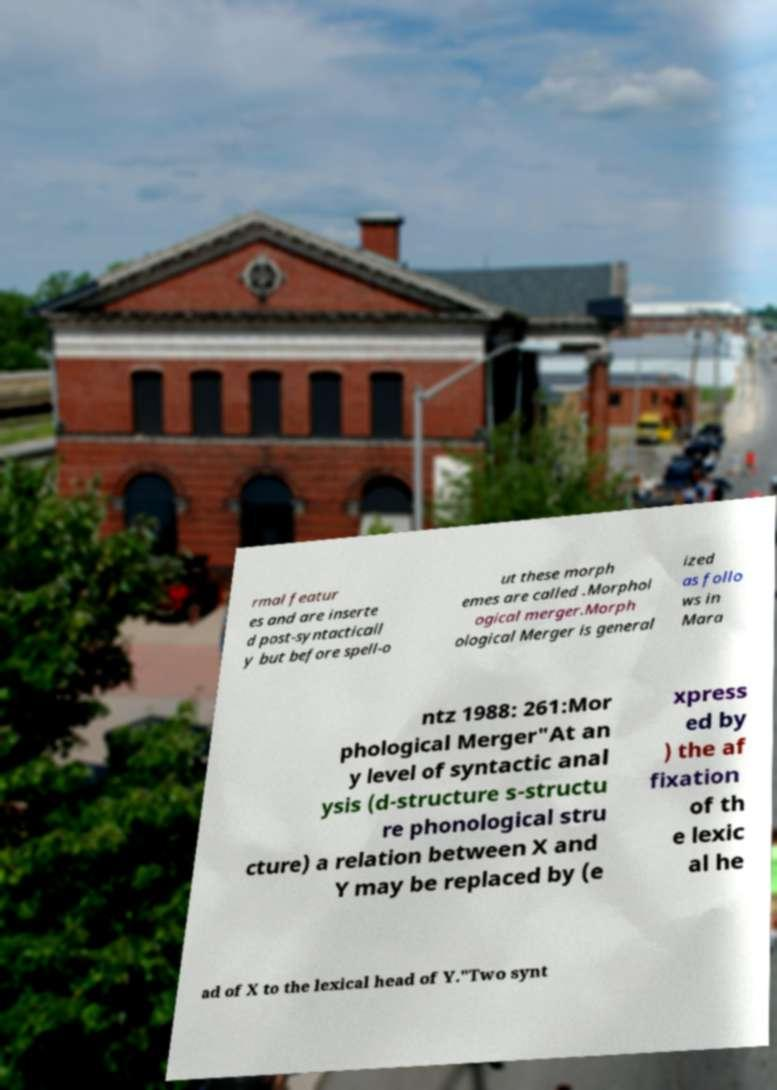Can you accurately transcribe the text from the provided image for me? rmal featur es and are inserte d post-syntacticall y but before spell-o ut these morph emes are called .Morphol ogical merger.Morph ological Merger is general ized as follo ws in Mara ntz 1988: 261:Mor phological Merger"At an y level of syntactic anal ysis (d-structure s-structu re phonological stru cture) a relation between X and Y may be replaced by (e xpress ed by ) the af fixation of th e lexic al he ad of X to the lexical head of Y."Two synt 